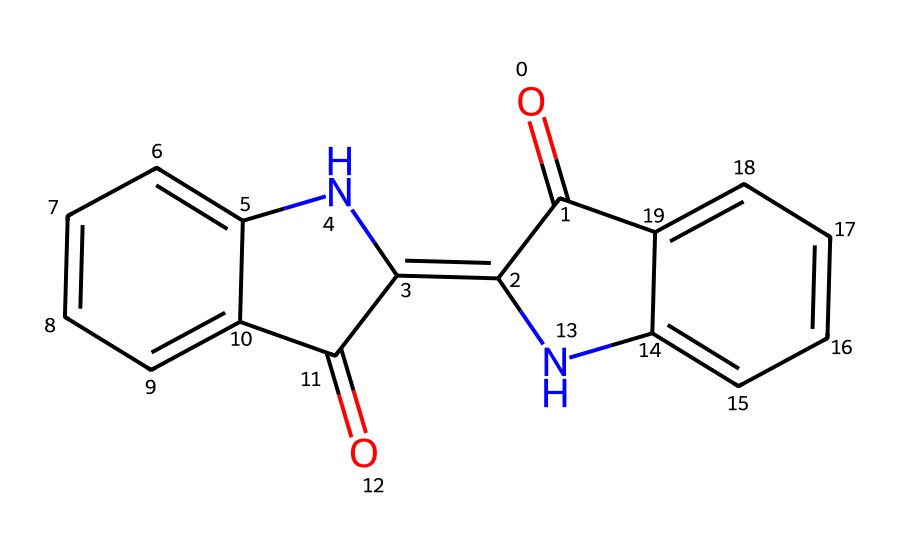What is the primary functional group present in the indigo dye structure? The structure contains a substantial amount of nitrogen and carbon atoms, including amide (C=O and N-H) functional groups, which are characteristic of indigo dye.
Answer: amide How many carbon atoms are in the indigo dye structure? By analyzing the provided SMILES representation, we can count the number of carbon atoms present. The structure consists of 16 carbon atoms in total.
Answer: 16 What type of chemical interaction is prominent due to the nitrogen atoms in this dye? The nitrogen atoms can participate in hydrogen bonding and affect the dye's solubility and interaction with fibers, indicating a strong interaction due to their polar nature.
Answer: hydrogen bonding What is the significance of the double bonds in the indigo structure? The alternating double bonds contribute to the dye's conjugated system, which helps in light absorption and enhances color properties, thus contributing to the covalent bonding stability and color permanence.
Answer: conjugated system How many rings are present in the indigo dye structure? By examining the chemical structure, we can identify that there are three fused aromatic rings in the indigo molecule, which significantly impacts its dye properties.
Answer: three What makes indigo dye particularly stable or permanent compared to other dyes? The structure of indigo features a robust conjugated system and resonance stabilization, which protects it from fading, along with strong intermolecular interactions from its aromatic structures.
Answer: conjugated system 